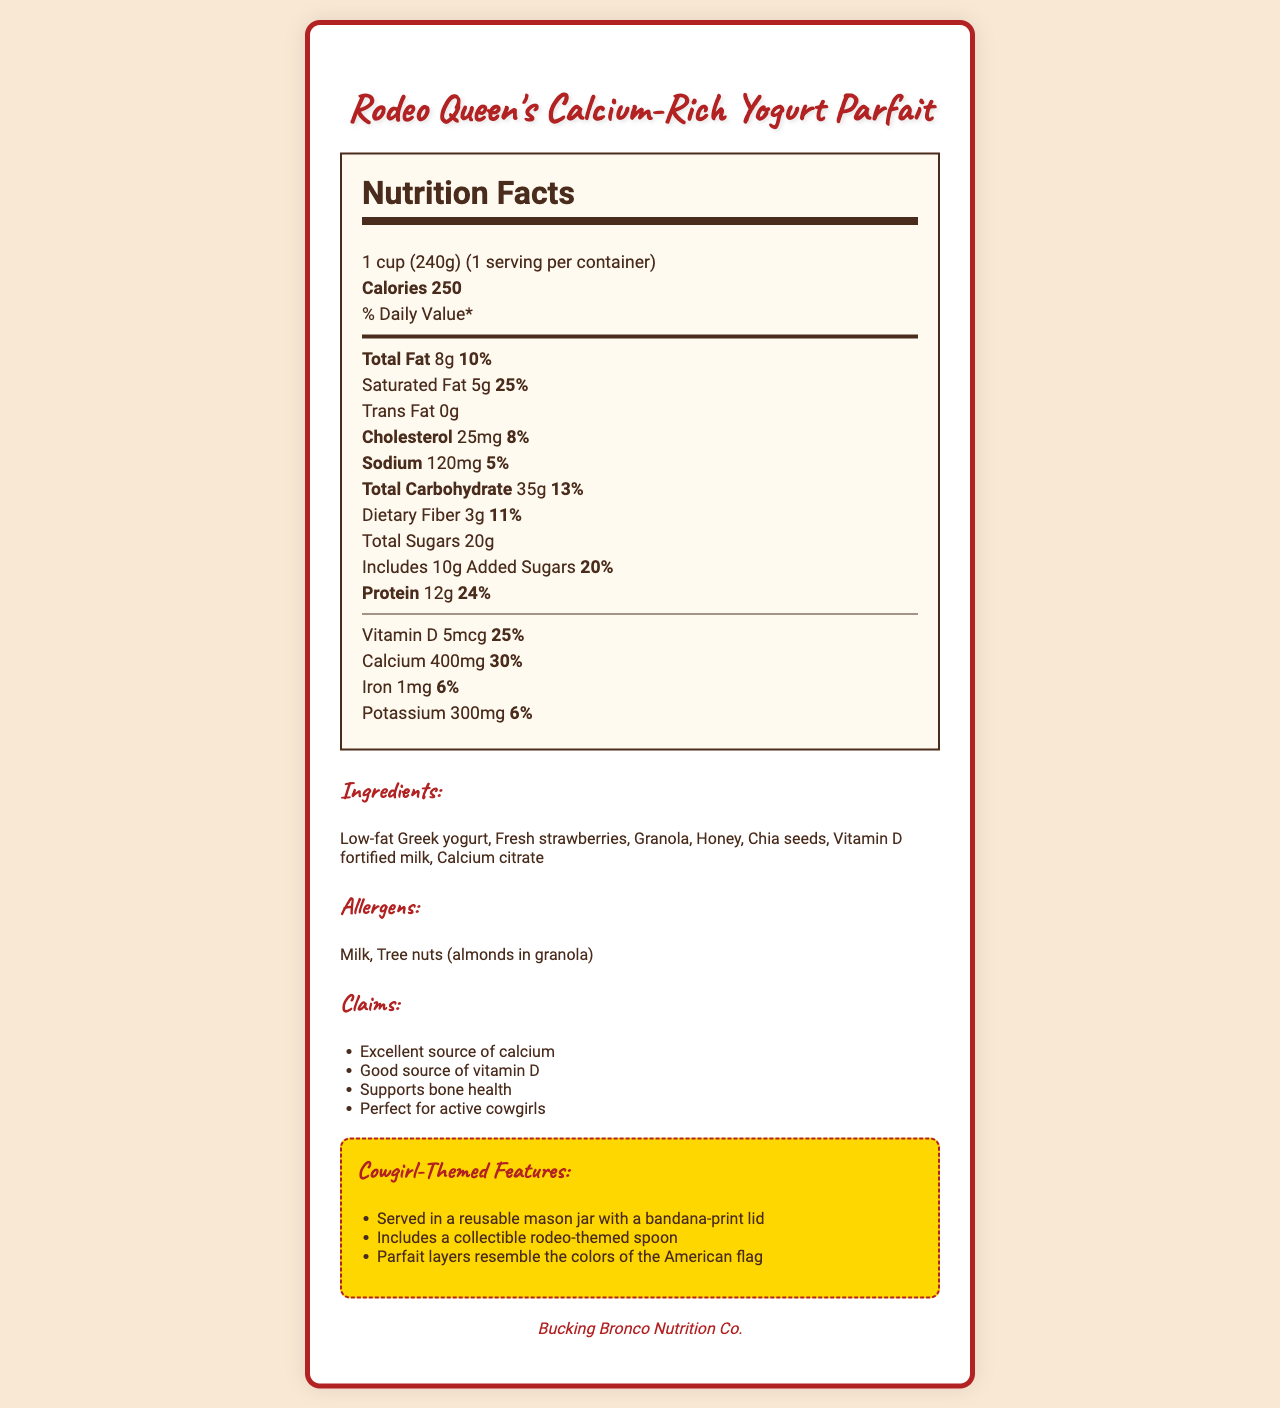what is the serving size? The document specifies that the serving size is 1 cup (240 grams).
Answer: 1 cup (240g) how many calories are in one serving? The document states that there are 250 calories per serving.
Answer: 250 name two allergens mentioned in the document. The allergens listed in the document include Milk and Tree nuts (almonds in granola).
Answer: Milk, Tree nuts (almonds in granola) what is the percentage of daily value for protein in the parfait? The document states that the protein content provides 24% of the daily value.
Answer: 24% what are some of the cowgirl-themed features of the parfait? The document highlights these cowgirl-themed features.
Answer: Served in a reusable mason jar with a bandana-print lid, Includes a collectible rodeo-themed spoon, Parfait layers resemble the colors of the American flag which ingredient is used for calcium fortification? A. Vitamin D fortified milk B. Calcium citrate C. Chia seeds D. Honey The document lists Calcium citrate as an ingredient, specifically for calcium fortification.
Answer: B. Calcium citrate how much dietary fiber is in one serving? A. 1g B. 2g C. 3g D. 4g The document states that each serving contains 3g of dietary fiber.
Answer: C. 3g is there any trans fat in the yogurt parfait? The document specifies that the trans fat content is 0g.
Answer: No summarize the main claims made about the yogurt parfait. The claims emphasize the parfait's nutritional benefits and its suitability for active cowgirls.
Answer: Excellent source of calcium, Good source of vitamin D, Supports bone health, Perfect for active cowgirls how much potassium is in the parfait? The document states that each serving contains 300mg of potassium.
Answer: 300mg can the document determine how many parfaits are typically sold per month? The document does not provide any sales data or statistics on the number of parfaits sold.
Answer: Not enough information what brand makes the Rodeo Queen's Calcium-Rich Yogurt Parfait? The brand information provided in the document is Bucking Bronco Nutrition Co.
Answer: Bucking Bronco Nutrition Co. 